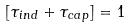Convert formula to latex. <formula><loc_0><loc_0><loc_500><loc_500>[ \tau _ { i n d } + \tau _ { c a p } ] = 1</formula> 